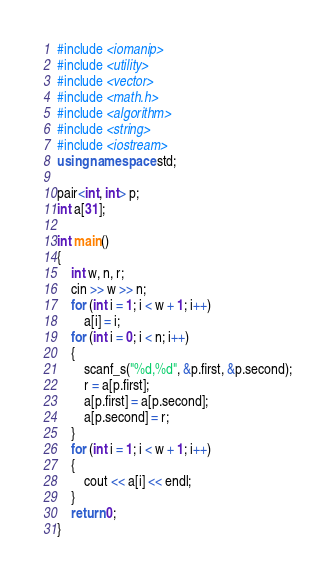Convert code to text. <code><loc_0><loc_0><loc_500><loc_500><_C++_>#include <iomanip>
#include <utility>
#include <vector>
#include <math.h>
#include <algorithm>
#include <string>
#include <iostream>
using namespace std;

pair<int, int> p;
int a[31];

int main()
{
	int w, n, r;
	cin >> w >> n;
	for (int i = 1; i < w + 1; i++)
		a[i] = i;
	for (int i = 0; i < n; i++)
	{
		scanf_s("%d,%d", &p.first, &p.second);
		r = a[p.first];
		a[p.first] = a[p.second];
		a[p.second] = r;
	}
	for (int i = 1; i < w + 1; i++)
	{
		cout << a[i] << endl;
	}
	return 0;
}</code> 